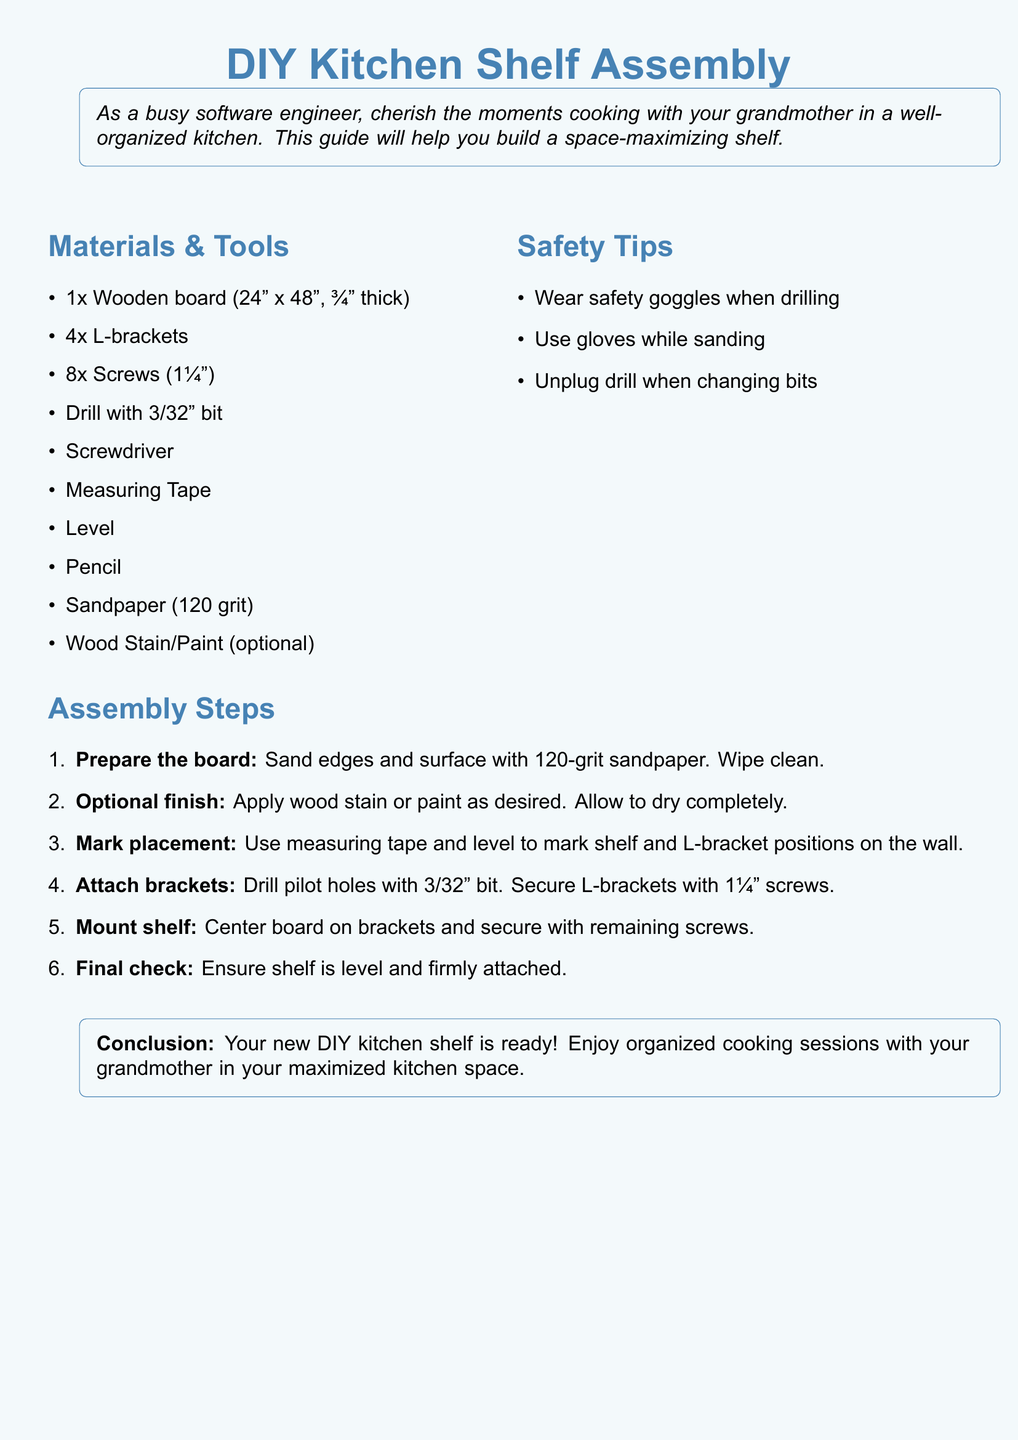What is the size of the wooden board? The document specifies that the wooden board should be 24" x 48".
Answer: 24" x 48" How many L-brackets are needed? The materials list mentions needing 4 L-brackets for the assembly.
Answer: 4 What tool is required to drill pilot holes? The instructions state a drill with a 3/32" bit is necessary for drilling pilot holes.
Answer: Drill with 3/32" bit What is the grit of the sandpaper recommended? The document advises using 120 grit sandpaper for preparing the wooden board.
Answer: 120 grit What is the last step of the assembly process? The final assembly step is to ensure the shelf is level and firmly attached.
Answer: Final check What safety equipment should be worn when drilling? The safety tips section indicates that safety goggles should be worn while drilling.
Answer: Safety goggles What should be done after sanding the board? The document states that after sanding, the next step is to wipe the board clean.
Answer: Wipe clean What is an optional finish mentioned in the instructions? The assembly guide includes applying wood stain or paint as an optional finish.
Answer: Wood stain/Paint 